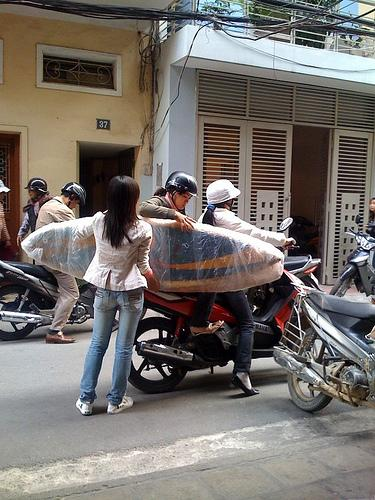What color is the background on the surfboard wrapped up with cello wrap?

Choices:
A) white
B) green
C) blue
D) yellow blue 